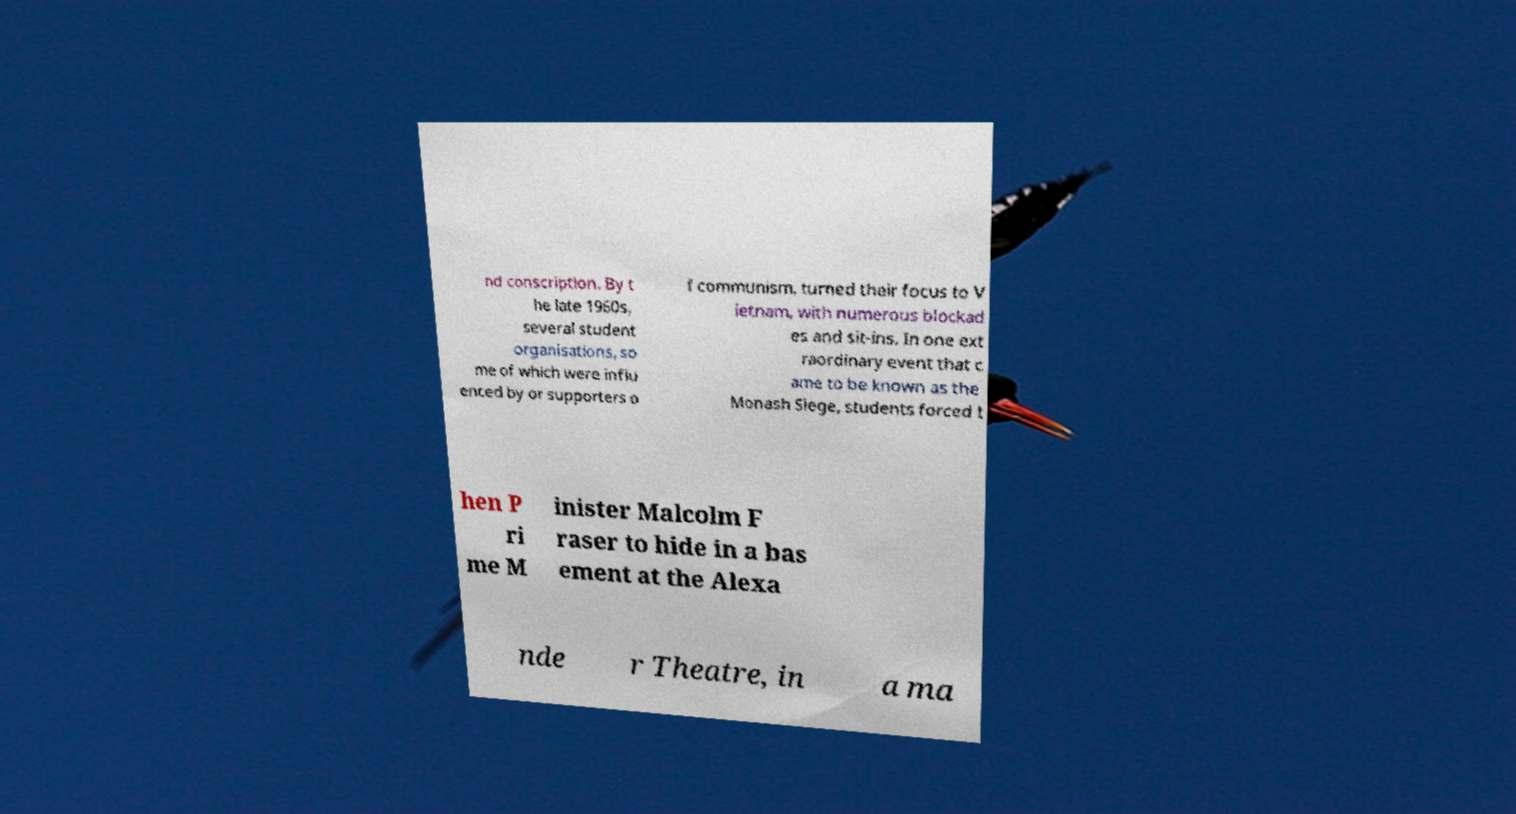For documentation purposes, I need the text within this image transcribed. Could you provide that? nd conscription. By t he late 1960s, several student organisations, so me of which were influ enced by or supporters o f communism, turned their focus to V ietnam, with numerous blockad es and sit-ins. In one ext raordinary event that c ame to be known as the Monash Siege, students forced t hen P ri me M inister Malcolm F raser to hide in a bas ement at the Alexa nde r Theatre, in a ma 